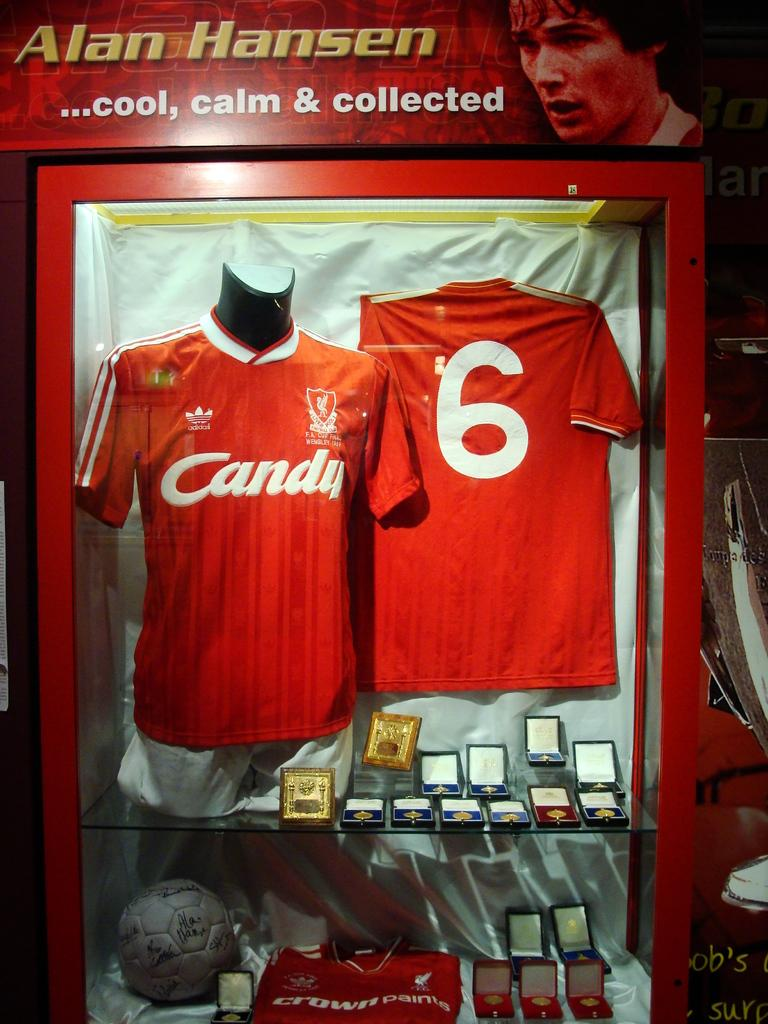<image>
Offer a succinct explanation of the picture presented. A display of awards and jerseys for Alan Hansen is in a glass case. 